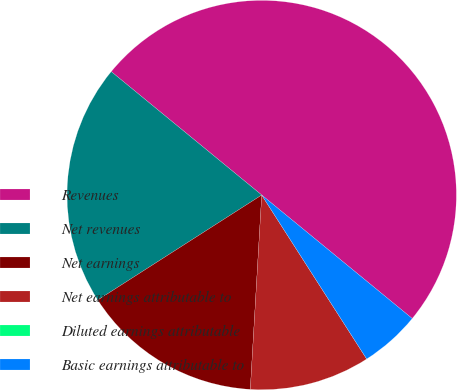Convert chart to OTSL. <chart><loc_0><loc_0><loc_500><loc_500><pie_chart><fcel>Revenues<fcel>Net revenues<fcel>Net earnings<fcel>Net earnings attributable to<fcel>Diluted earnings attributable<fcel>Basic earnings attributable to<nl><fcel>50.0%<fcel>20.0%<fcel>15.0%<fcel>10.0%<fcel>0.0%<fcel>5.0%<nl></chart> 